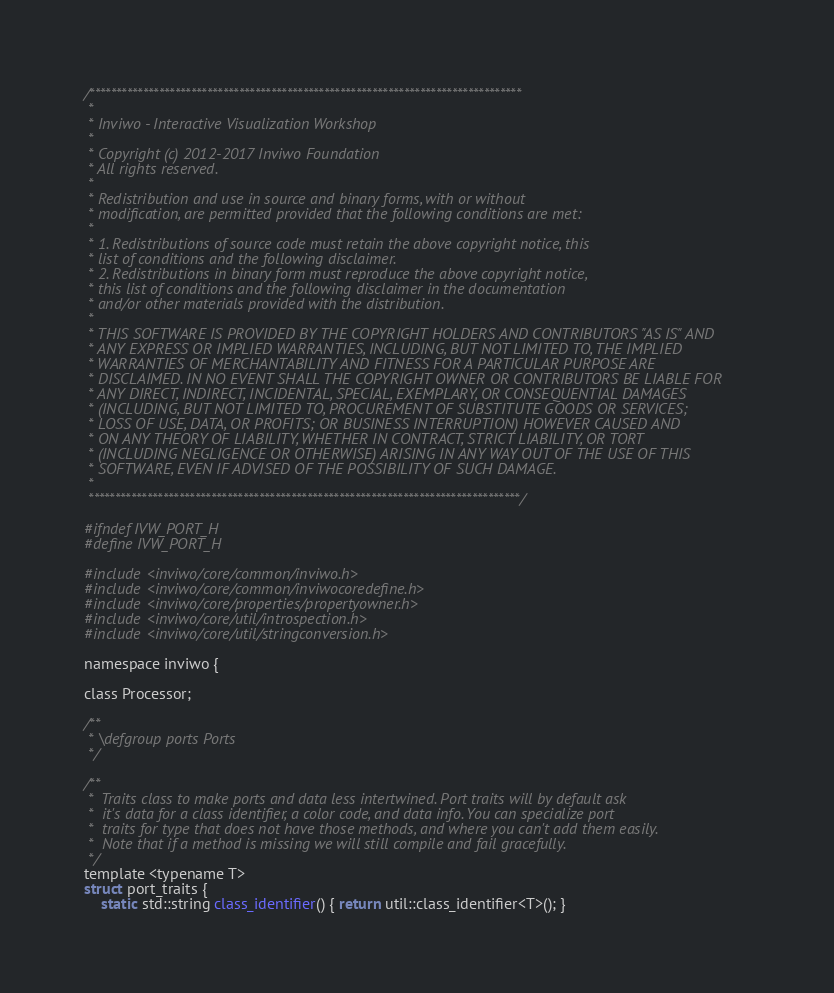Convert code to text. <code><loc_0><loc_0><loc_500><loc_500><_C_>/*********************************************************************************
 *
 * Inviwo - Interactive Visualization Workshop
 *
 * Copyright (c) 2012-2017 Inviwo Foundation
 * All rights reserved.
 *
 * Redistribution and use in source and binary forms, with or without
 * modification, are permitted provided that the following conditions are met:
 *
 * 1. Redistributions of source code must retain the above copyright notice, this
 * list of conditions and the following disclaimer.
 * 2. Redistributions in binary form must reproduce the above copyright notice,
 * this list of conditions and the following disclaimer in the documentation
 * and/or other materials provided with the distribution.
 *
 * THIS SOFTWARE IS PROVIDED BY THE COPYRIGHT HOLDERS AND CONTRIBUTORS "AS IS" AND
 * ANY EXPRESS OR IMPLIED WARRANTIES, INCLUDING, BUT NOT LIMITED TO, THE IMPLIED
 * WARRANTIES OF MERCHANTABILITY AND FITNESS FOR A PARTICULAR PURPOSE ARE
 * DISCLAIMED. IN NO EVENT SHALL THE COPYRIGHT OWNER OR CONTRIBUTORS BE LIABLE FOR
 * ANY DIRECT, INDIRECT, INCIDENTAL, SPECIAL, EXEMPLARY, OR CONSEQUENTIAL DAMAGES
 * (INCLUDING, BUT NOT LIMITED TO, PROCUREMENT OF SUBSTITUTE GOODS OR SERVICES;
 * LOSS OF USE, DATA, OR PROFITS; OR BUSINESS INTERRUPTION) HOWEVER CAUSED AND
 * ON ANY THEORY OF LIABILITY, WHETHER IN CONTRACT, STRICT LIABILITY, OR TORT
 * (INCLUDING NEGLIGENCE OR OTHERWISE) ARISING IN ANY WAY OUT OF THE USE OF THIS
 * SOFTWARE, EVEN IF ADVISED OF THE POSSIBILITY OF SUCH DAMAGE.
 *
 *********************************************************************************/

#ifndef IVW_PORT_H
#define IVW_PORT_H

#include <inviwo/core/common/inviwo.h>
#include <inviwo/core/common/inviwocoredefine.h>
#include <inviwo/core/properties/propertyowner.h>
#include <inviwo/core/util/introspection.h>
#include <inviwo/core/util/stringconversion.h>

namespace inviwo {

class Processor;

/**
 * \defgroup ports Ports
 */

/**
 *  Traits class to make ports and data less intertwined. Port traits will by default ask
 *  it's data for a class identifier, a color code, and data info. You can specialize port
 *  traits for type that does not have those methods, and where you can't add them easily.
 *  Note that if a method is missing we will still compile and fail gracefully.
 */
template <typename T>
struct port_traits {
    static std::string class_identifier() { return util::class_identifier<T>(); }</code> 